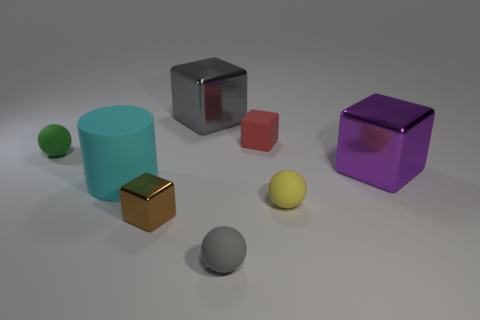Add 1 purple rubber things. How many objects exist? 9 Subtract all green spheres. How many spheres are left? 2 Subtract all gray balls. How many balls are left? 2 Subtract all balls. How many objects are left? 5 Subtract 1 cylinders. How many cylinders are left? 0 Subtract all cyan cubes. Subtract all purple cylinders. How many cubes are left? 4 Subtract all brown cubes. How many green spheres are left? 1 Subtract all purple objects. Subtract all red objects. How many objects are left? 6 Add 6 small red objects. How many small red objects are left? 7 Add 4 purple metallic blocks. How many purple metallic blocks exist? 5 